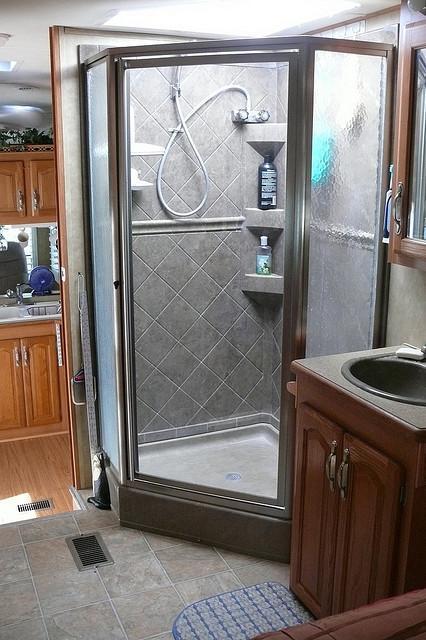How many bottles are in the shower?
Give a very brief answer. 2. 